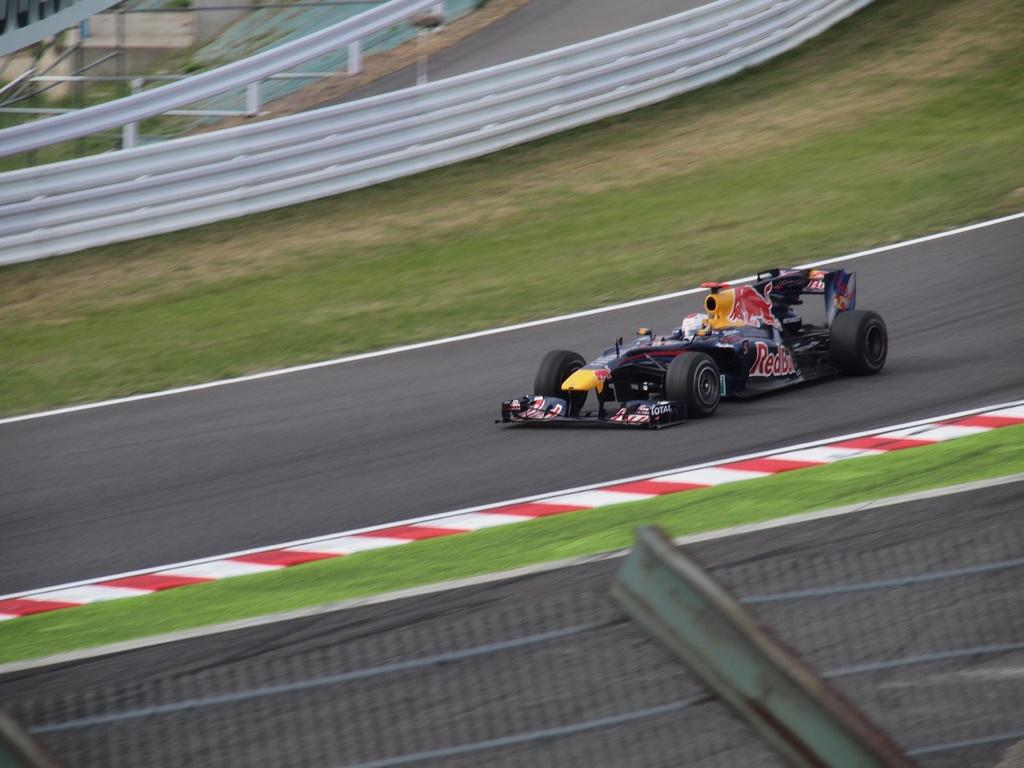What type of vehicle is in the image? There is a sports car in the image. Where is the sports car located? The sports car is on the road. What can be seen in the background of the image? There is grass and a railing visible in the background of the image. How does the sports car swim in the image? The sports car does not swim in the image; it is on the road. What relation does the sports car have with the railing in the image? The sports car is not related to the railing in the image; they are separate elements in the scene. 